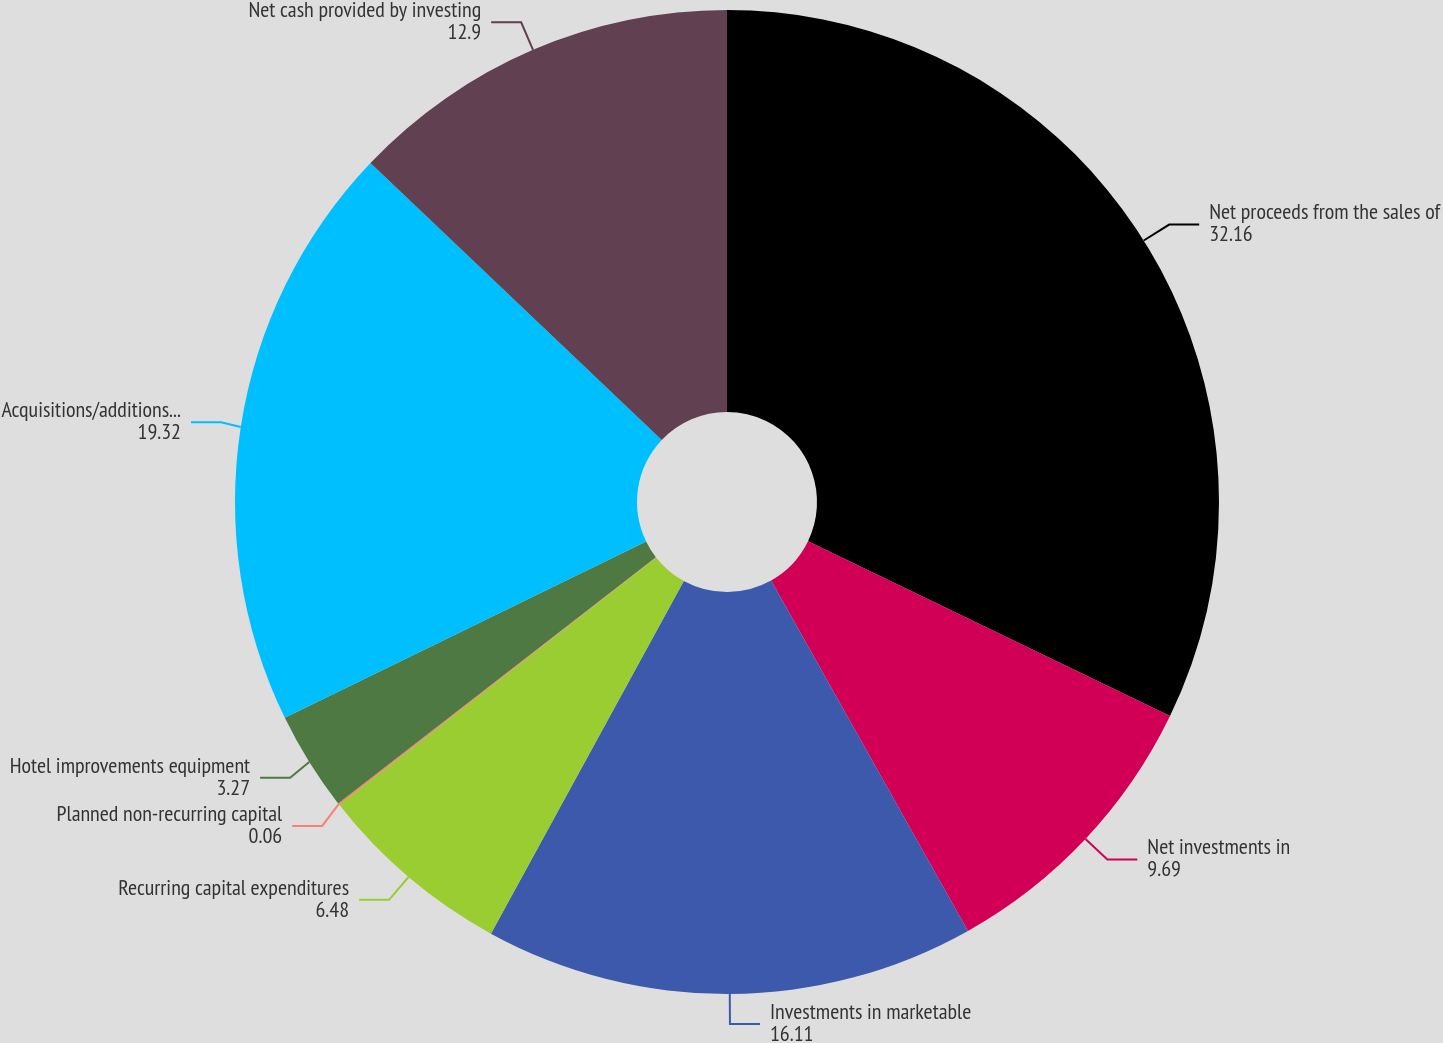<chart> <loc_0><loc_0><loc_500><loc_500><pie_chart><fcel>Net proceeds from the sales of<fcel>Net investments in<fcel>Investments in marketable<fcel>Recurring capital expenditures<fcel>Planned non-recurring capital<fcel>Hotel improvements equipment<fcel>Acquisitions/additions to real<fcel>Net cash provided by investing<nl><fcel>32.16%<fcel>9.69%<fcel>16.11%<fcel>6.48%<fcel>0.06%<fcel>3.27%<fcel>19.32%<fcel>12.9%<nl></chart> 